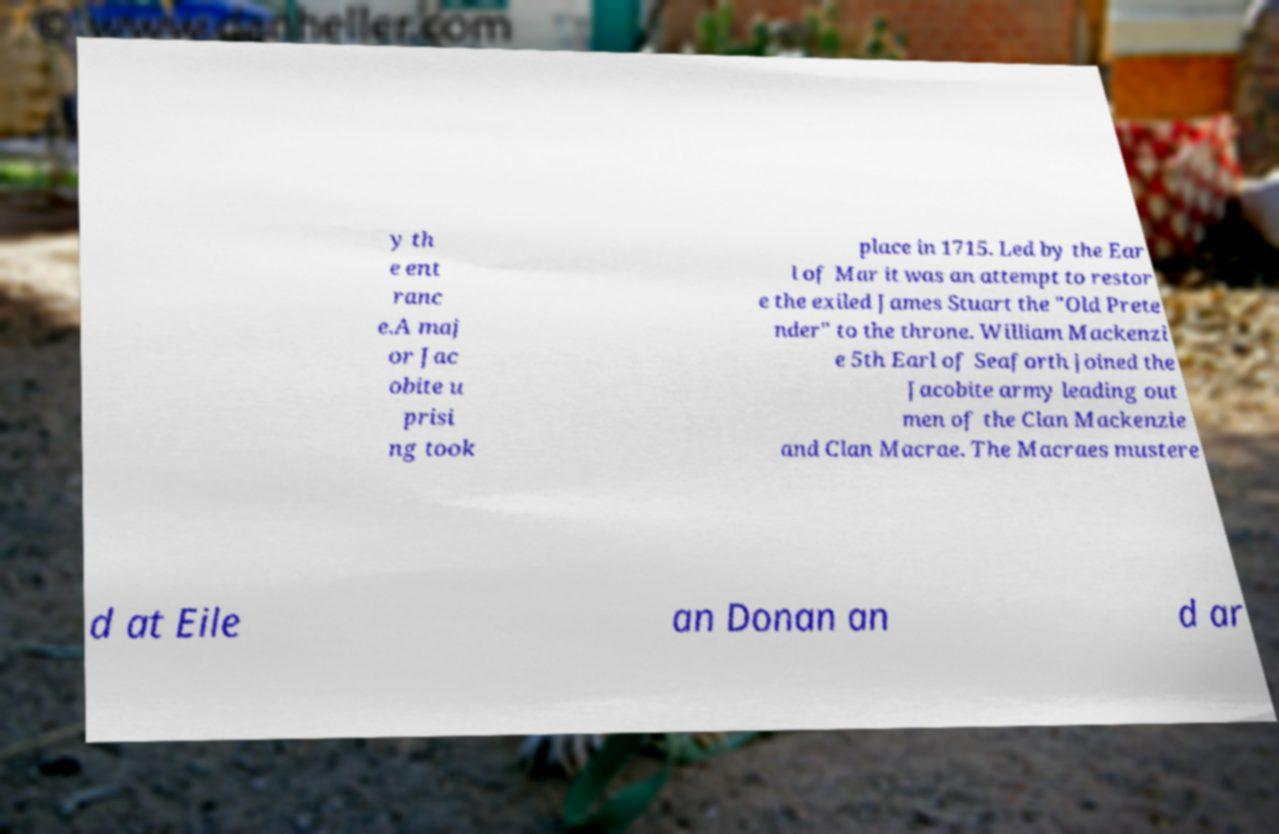Can you accurately transcribe the text from the provided image for me? y th e ent ranc e.A maj or Jac obite u prisi ng took place in 1715. Led by the Ear l of Mar it was an attempt to restor e the exiled James Stuart the "Old Prete nder" to the throne. William Mackenzi e 5th Earl of Seaforth joined the Jacobite army leading out men of the Clan Mackenzie and Clan Macrae. The Macraes mustere d at Eile an Donan an d ar 